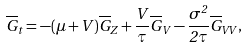Convert formula to latex. <formula><loc_0><loc_0><loc_500><loc_500>\overline { G } _ { t } = - ( \mu + V ) \overline { G } _ { Z } + \frac { V } { \tau } \overline { G } _ { V } - \frac { \sigma ^ { 2 } } { 2 \tau } \overline { G } _ { V V } ,</formula> 